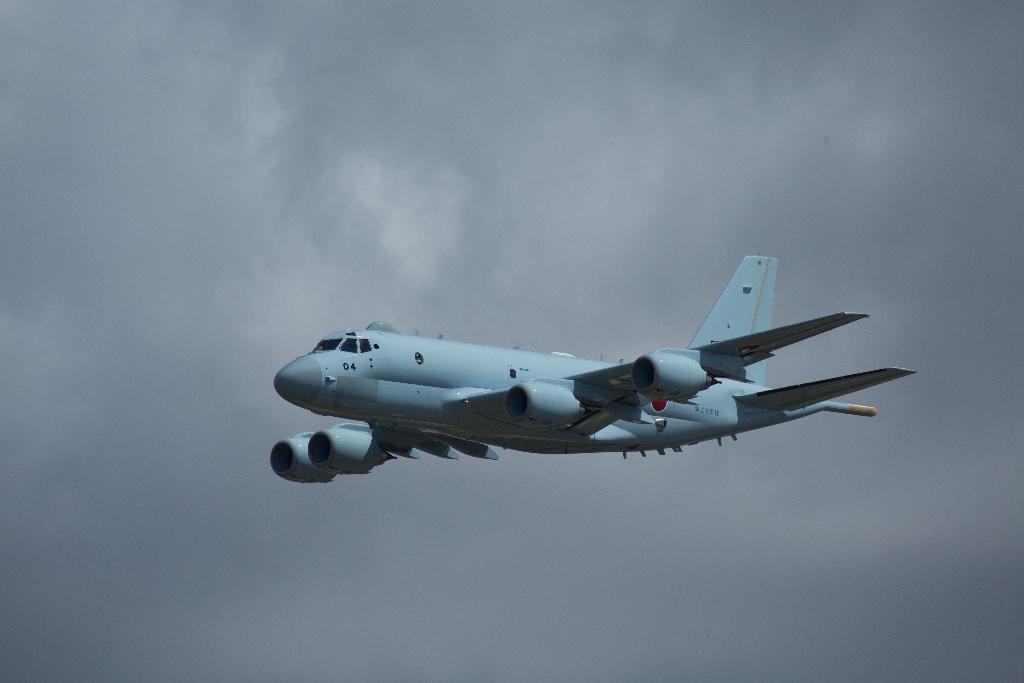What is the main subject of the image? The main subject of the image is a plane. What is the plane doing in the image? The plane is flying in the sky. What can be seen in the background of the image? There are clouds in the background of the image. What type of liquid is being poured out of the plane in the image? A: There is no liquid being poured out of the plane in the image; the plane is simply flying in the sky. What song is being sung by the passengers on the plane in the image? There is no indication of any passengers or singing in the image; it only shows a plane flying in the sky. 